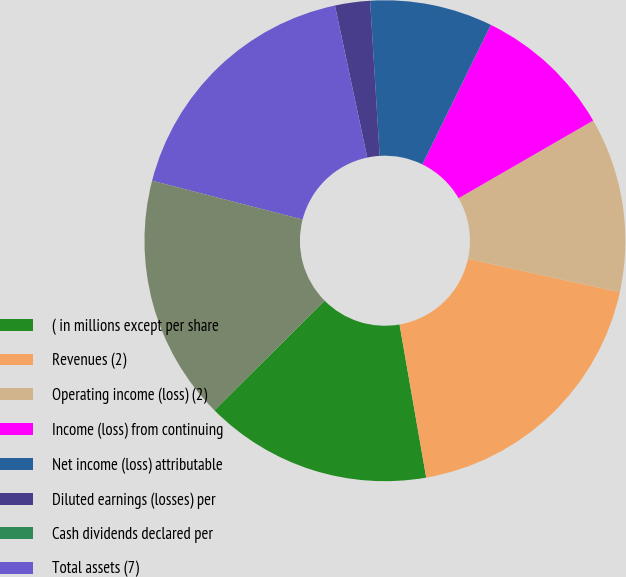<chart> <loc_0><loc_0><loc_500><loc_500><pie_chart><fcel>( in millions except per share<fcel>Revenues (2)<fcel>Operating income (loss) (2)<fcel>Income (loss) from continuing<fcel>Net income (loss) attributable<fcel>Diluted earnings (losses) per<fcel>Cash dividends declared per<fcel>Total assets (7)<fcel>Long-term debt (7)<nl><fcel>15.29%<fcel>18.82%<fcel>11.76%<fcel>9.41%<fcel>8.24%<fcel>2.35%<fcel>0.0%<fcel>17.65%<fcel>16.47%<nl></chart> 